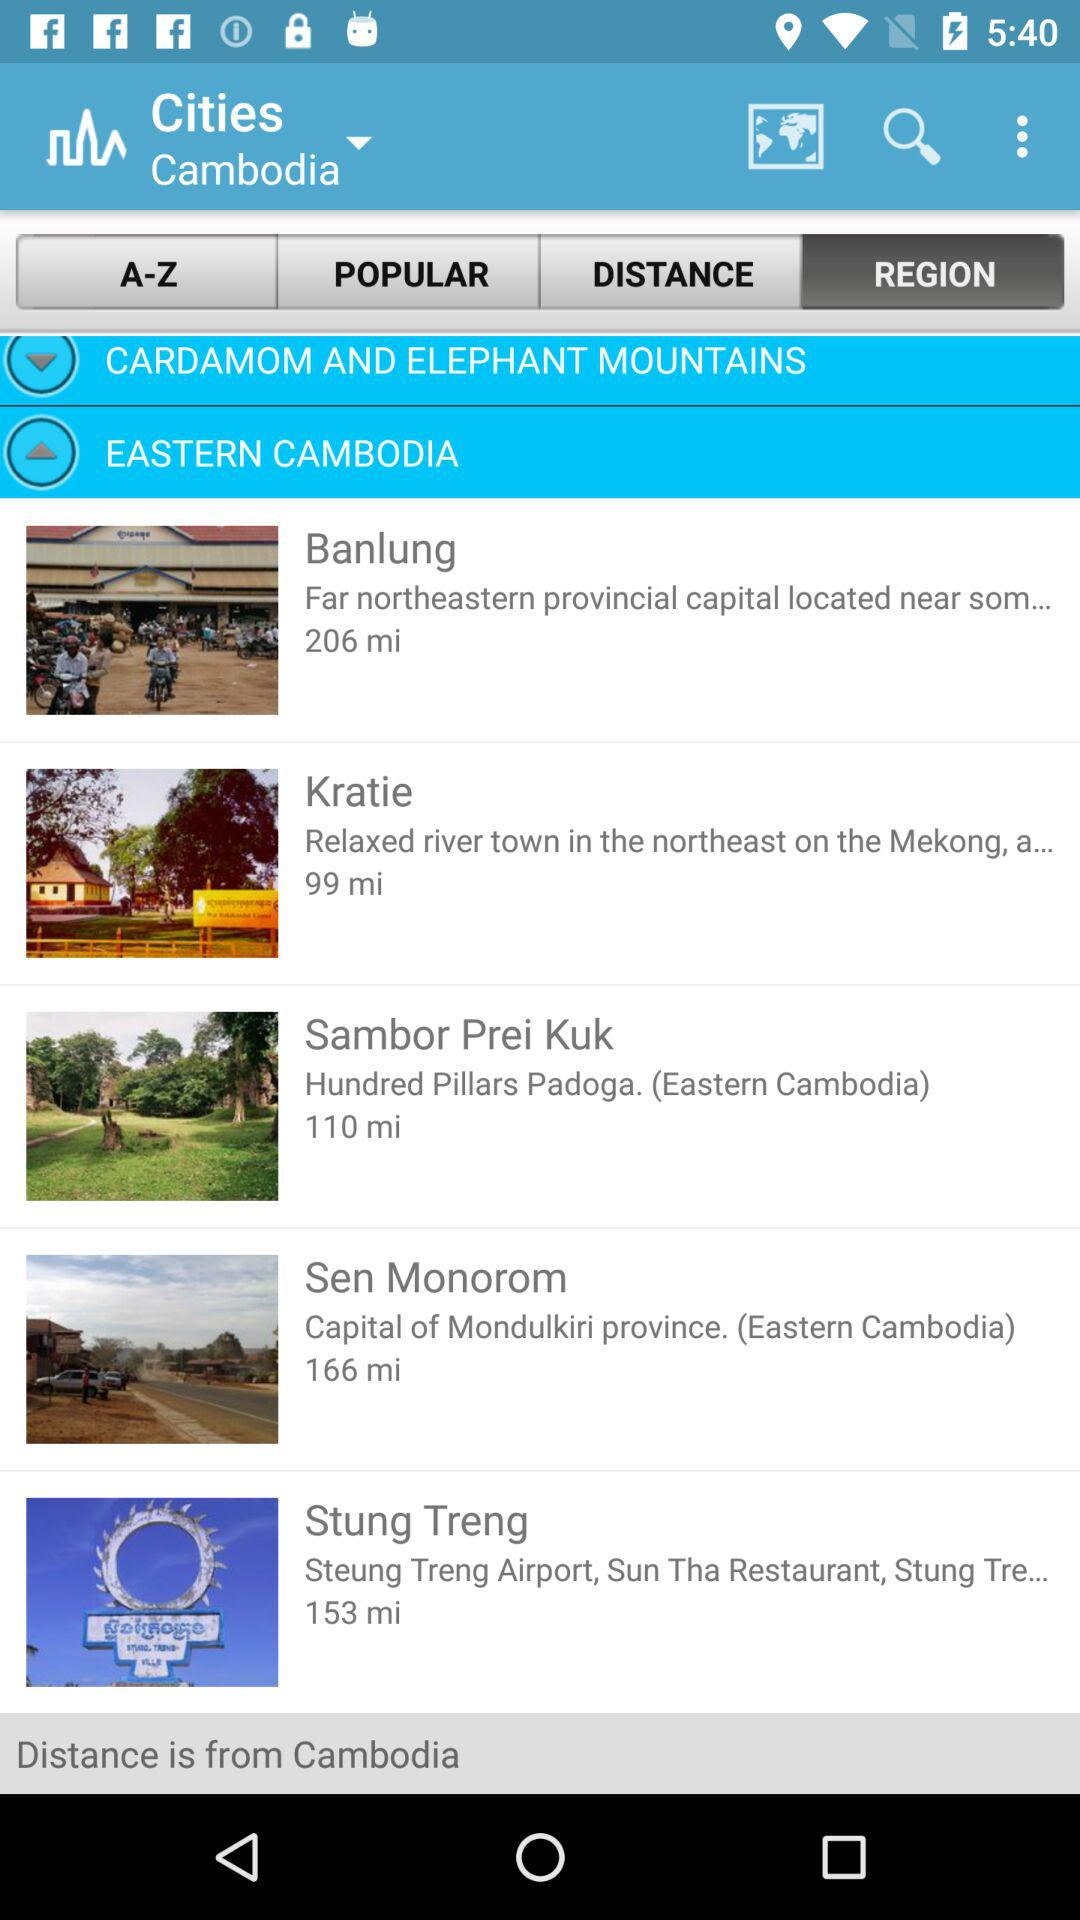What is the capital of Mondulkiri? The capital of Mondulkiri is Sen Monorom. 